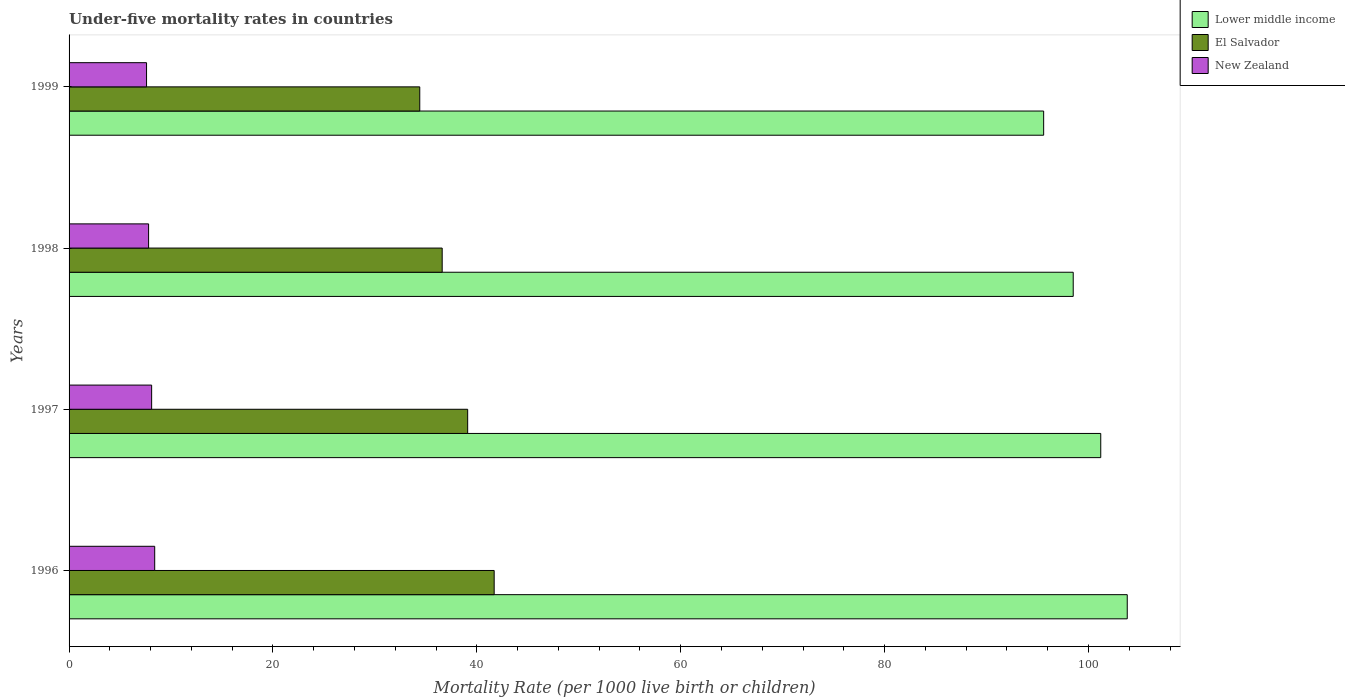How many groups of bars are there?
Your response must be concise. 4. What is the label of the 3rd group of bars from the top?
Ensure brevity in your answer.  1997. What is the under-five mortality rate in Lower middle income in 1997?
Offer a very short reply. 101.2. Across all years, what is the maximum under-five mortality rate in El Salvador?
Give a very brief answer. 41.7. Across all years, what is the minimum under-five mortality rate in Lower middle income?
Your response must be concise. 95.6. What is the total under-five mortality rate in Lower middle income in the graph?
Provide a short and direct response. 399.1. What is the difference between the under-five mortality rate in Lower middle income in 1996 and the under-five mortality rate in El Salvador in 1997?
Keep it short and to the point. 64.7. What is the average under-five mortality rate in New Zealand per year?
Make the answer very short. 7.97. In the year 1998, what is the difference between the under-five mortality rate in New Zealand and under-five mortality rate in Lower middle income?
Give a very brief answer. -90.7. What is the ratio of the under-five mortality rate in New Zealand in 1996 to that in 1997?
Provide a short and direct response. 1.04. Is the under-five mortality rate in El Salvador in 1996 less than that in 1999?
Your answer should be very brief. No. What is the difference between the highest and the second highest under-five mortality rate in Lower middle income?
Offer a terse response. 2.6. What is the difference between the highest and the lowest under-five mortality rate in El Salvador?
Your answer should be compact. 7.3. In how many years, is the under-five mortality rate in New Zealand greater than the average under-five mortality rate in New Zealand taken over all years?
Provide a succinct answer. 2. What does the 2nd bar from the top in 1996 represents?
Provide a short and direct response. El Salvador. What does the 1st bar from the bottom in 1996 represents?
Ensure brevity in your answer.  Lower middle income. How many bars are there?
Keep it short and to the point. 12. Where does the legend appear in the graph?
Offer a very short reply. Top right. How are the legend labels stacked?
Your answer should be compact. Vertical. What is the title of the graph?
Keep it short and to the point. Under-five mortality rates in countries. What is the label or title of the X-axis?
Keep it short and to the point. Mortality Rate (per 1000 live birth or children). What is the label or title of the Y-axis?
Provide a succinct answer. Years. What is the Mortality Rate (per 1000 live birth or children) in Lower middle income in 1996?
Ensure brevity in your answer.  103.8. What is the Mortality Rate (per 1000 live birth or children) of El Salvador in 1996?
Provide a succinct answer. 41.7. What is the Mortality Rate (per 1000 live birth or children) in New Zealand in 1996?
Your response must be concise. 8.4. What is the Mortality Rate (per 1000 live birth or children) of Lower middle income in 1997?
Ensure brevity in your answer.  101.2. What is the Mortality Rate (per 1000 live birth or children) of El Salvador in 1997?
Your answer should be very brief. 39.1. What is the Mortality Rate (per 1000 live birth or children) in New Zealand in 1997?
Offer a very short reply. 8.1. What is the Mortality Rate (per 1000 live birth or children) of Lower middle income in 1998?
Provide a succinct answer. 98.5. What is the Mortality Rate (per 1000 live birth or children) in El Salvador in 1998?
Keep it short and to the point. 36.6. What is the Mortality Rate (per 1000 live birth or children) in Lower middle income in 1999?
Give a very brief answer. 95.6. What is the Mortality Rate (per 1000 live birth or children) in El Salvador in 1999?
Give a very brief answer. 34.4. Across all years, what is the maximum Mortality Rate (per 1000 live birth or children) in Lower middle income?
Your answer should be compact. 103.8. Across all years, what is the maximum Mortality Rate (per 1000 live birth or children) in El Salvador?
Provide a succinct answer. 41.7. Across all years, what is the minimum Mortality Rate (per 1000 live birth or children) of Lower middle income?
Ensure brevity in your answer.  95.6. Across all years, what is the minimum Mortality Rate (per 1000 live birth or children) of El Salvador?
Ensure brevity in your answer.  34.4. What is the total Mortality Rate (per 1000 live birth or children) in Lower middle income in the graph?
Provide a short and direct response. 399.1. What is the total Mortality Rate (per 1000 live birth or children) in El Salvador in the graph?
Provide a short and direct response. 151.8. What is the total Mortality Rate (per 1000 live birth or children) in New Zealand in the graph?
Ensure brevity in your answer.  31.9. What is the difference between the Mortality Rate (per 1000 live birth or children) in Lower middle income in 1996 and that in 1997?
Make the answer very short. 2.6. What is the difference between the Mortality Rate (per 1000 live birth or children) in New Zealand in 1996 and that in 1997?
Provide a short and direct response. 0.3. What is the difference between the Mortality Rate (per 1000 live birth or children) in Lower middle income in 1996 and that in 1998?
Your response must be concise. 5.3. What is the difference between the Mortality Rate (per 1000 live birth or children) of El Salvador in 1996 and that in 1998?
Your answer should be very brief. 5.1. What is the difference between the Mortality Rate (per 1000 live birth or children) in El Salvador in 1996 and that in 1999?
Your answer should be compact. 7.3. What is the difference between the Mortality Rate (per 1000 live birth or children) of New Zealand in 1996 and that in 1999?
Your answer should be compact. 0.8. What is the difference between the Mortality Rate (per 1000 live birth or children) of Lower middle income in 1997 and that in 1998?
Give a very brief answer. 2.7. What is the difference between the Mortality Rate (per 1000 live birth or children) in El Salvador in 1997 and that in 1998?
Give a very brief answer. 2.5. What is the difference between the Mortality Rate (per 1000 live birth or children) in Lower middle income in 1997 and that in 1999?
Make the answer very short. 5.6. What is the difference between the Mortality Rate (per 1000 live birth or children) in El Salvador in 1997 and that in 1999?
Your answer should be very brief. 4.7. What is the difference between the Mortality Rate (per 1000 live birth or children) in Lower middle income in 1998 and that in 1999?
Your response must be concise. 2.9. What is the difference between the Mortality Rate (per 1000 live birth or children) in El Salvador in 1998 and that in 1999?
Your answer should be compact. 2.2. What is the difference between the Mortality Rate (per 1000 live birth or children) of Lower middle income in 1996 and the Mortality Rate (per 1000 live birth or children) of El Salvador in 1997?
Provide a succinct answer. 64.7. What is the difference between the Mortality Rate (per 1000 live birth or children) of Lower middle income in 1996 and the Mortality Rate (per 1000 live birth or children) of New Zealand in 1997?
Ensure brevity in your answer.  95.7. What is the difference between the Mortality Rate (per 1000 live birth or children) in El Salvador in 1996 and the Mortality Rate (per 1000 live birth or children) in New Zealand in 1997?
Keep it short and to the point. 33.6. What is the difference between the Mortality Rate (per 1000 live birth or children) in Lower middle income in 1996 and the Mortality Rate (per 1000 live birth or children) in El Salvador in 1998?
Offer a very short reply. 67.2. What is the difference between the Mortality Rate (per 1000 live birth or children) of Lower middle income in 1996 and the Mortality Rate (per 1000 live birth or children) of New Zealand in 1998?
Make the answer very short. 96. What is the difference between the Mortality Rate (per 1000 live birth or children) in El Salvador in 1996 and the Mortality Rate (per 1000 live birth or children) in New Zealand in 1998?
Provide a short and direct response. 33.9. What is the difference between the Mortality Rate (per 1000 live birth or children) in Lower middle income in 1996 and the Mortality Rate (per 1000 live birth or children) in El Salvador in 1999?
Make the answer very short. 69.4. What is the difference between the Mortality Rate (per 1000 live birth or children) of Lower middle income in 1996 and the Mortality Rate (per 1000 live birth or children) of New Zealand in 1999?
Provide a succinct answer. 96.2. What is the difference between the Mortality Rate (per 1000 live birth or children) in El Salvador in 1996 and the Mortality Rate (per 1000 live birth or children) in New Zealand in 1999?
Your response must be concise. 34.1. What is the difference between the Mortality Rate (per 1000 live birth or children) in Lower middle income in 1997 and the Mortality Rate (per 1000 live birth or children) in El Salvador in 1998?
Ensure brevity in your answer.  64.6. What is the difference between the Mortality Rate (per 1000 live birth or children) of Lower middle income in 1997 and the Mortality Rate (per 1000 live birth or children) of New Zealand in 1998?
Ensure brevity in your answer.  93.4. What is the difference between the Mortality Rate (per 1000 live birth or children) of El Salvador in 1997 and the Mortality Rate (per 1000 live birth or children) of New Zealand in 1998?
Your answer should be very brief. 31.3. What is the difference between the Mortality Rate (per 1000 live birth or children) in Lower middle income in 1997 and the Mortality Rate (per 1000 live birth or children) in El Salvador in 1999?
Keep it short and to the point. 66.8. What is the difference between the Mortality Rate (per 1000 live birth or children) of Lower middle income in 1997 and the Mortality Rate (per 1000 live birth or children) of New Zealand in 1999?
Offer a terse response. 93.6. What is the difference between the Mortality Rate (per 1000 live birth or children) in El Salvador in 1997 and the Mortality Rate (per 1000 live birth or children) in New Zealand in 1999?
Provide a short and direct response. 31.5. What is the difference between the Mortality Rate (per 1000 live birth or children) in Lower middle income in 1998 and the Mortality Rate (per 1000 live birth or children) in El Salvador in 1999?
Your answer should be very brief. 64.1. What is the difference between the Mortality Rate (per 1000 live birth or children) in Lower middle income in 1998 and the Mortality Rate (per 1000 live birth or children) in New Zealand in 1999?
Provide a succinct answer. 90.9. What is the difference between the Mortality Rate (per 1000 live birth or children) in El Salvador in 1998 and the Mortality Rate (per 1000 live birth or children) in New Zealand in 1999?
Your answer should be compact. 29. What is the average Mortality Rate (per 1000 live birth or children) in Lower middle income per year?
Provide a succinct answer. 99.78. What is the average Mortality Rate (per 1000 live birth or children) in El Salvador per year?
Ensure brevity in your answer.  37.95. What is the average Mortality Rate (per 1000 live birth or children) in New Zealand per year?
Provide a short and direct response. 7.97. In the year 1996, what is the difference between the Mortality Rate (per 1000 live birth or children) of Lower middle income and Mortality Rate (per 1000 live birth or children) of El Salvador?
Provide a succinct answer. 62.1. In the year 1996, what is the difference between the Mortality Rate (per 1000 live birth or children) of Lower middle income and Mortality Rate (per 1000 live birth or children) of New Zealand?
Offer a very short reply. 95.4. In the year 1996, what is the difference between the Mortality Rate (per 1000 live birth or children) in El Salvador and Mortality Rate (per 1000 live birth or children) in New Zealand?
Ensure brevity in your answer.  33.3. In the year 1997, what is the difference between the Mortality Rate (per 1000 live birth or children) in Lower middle income and Mortality Rate (per 1000 live birth or children) in El Salvador?
Your answer should be very brief. 62.1. In the year 1997, what is the difference between the Mortality Rate (per 1000 live birth or children) of Lower middle income and Mortality Rate (per 1000 live birth or children) of New Zealand?
Your answer should be very brief. 93.1. In the year 1997, what is the difference between the Mortality Rate (per 1000 live birth or children) in El Salvador and Mortality Rate (per 1000 live birth or children) in New Zealand?
Offer a terse response. 31. In the year 1998, what is the difference between the Mortality Rate (per 1000 live birth or children) in Lower middle income and Mortality Rate (per 1000 live birth or children) in El Salvador?
Provide a succinct answer. 61.9. In the year 1998, what is the difference between the Mortality Rate (per 1000 live birth or children) in Lower middle income and Mortality Rate (per 1000 live birth or children) in New Zealand?
Make the answer very short. 90.7. In the year 1998, what is the difference between the Mortality Rate (per 1000 live birth or children) of El Salvador and Mortality Rate (per 1000 live birth or children) of New Zealand?
Your answer should be very brief. 28.8. In the year 1999, what is the difference between the Mortality Rate (per 1000 live birth or children) of Lower middle income and Mortality Rate (per 1000 live birth or children) of El Salvador?
Provide a short and direct response. 61.2. In the year 1999, what is the difference between the Mortality Rate (per 1000 live birth or children) of Lower middle income and Mortality Rate (per 1000 live birth or children) of New Zealand?
Offer a terse response. 88. In the year 1999, what is the difference between the Mortality Rate (per 1000 live birth or children) in El Salvador and Mortality Rate (per 1000 live birth or children) in New Zealand?
Ensure brevity in your answer.  26.8. What is the ratio of the Mortality Rate (per 1000 live birth or children) in Lower middle income in 1996 to that in 1997?
Make the answer very short. 1.03. What is the ratio of the Mortality Rate (per 1000 live birth or children) of El Salvador in 1996 to that in 1997?
Your answer should be very brief. 1.07. What is the ratio of the Mortality Rate (per 1000 live birth or children) in New Zealand in 1996 to that in 1997?
Provide a short and direct response. 1.04. What is the ratio of the Mortality Rate (per 1000 live birth or children) of Lower middle income in 1996 to that in 1998?
Your answer should be compact. 1.05. What is the ratio of the Mortality Rate (per 1000 live birth or children) of El Salvador in 1996 to that in 1998?
Make the answer very short. 1.14. What is the ratio of the Mortality Rate (per 1000 live birth or children) in New Zealand in 1996 to that in 1998?
Provide a succinct answer. 1.08. What is the ratio of the Mortality Rate (per 1000 live birth or children) in Lower middle income in 1996 to that in 1999?
Give a very brief answer. 1.09. What is the ratio of the Mortality Rate (per 1000 live birth or children) of El Salvador in 1996 to that in 1999?
Offer a terse response. 1.21. What is the ratio of the Mortality Rate (per 1000 live birth or children) of New Zealand in 1996 to that in 1999?
Offer a terse response. 1.11. What is the ratio of the Mortality Rate (per 1000 live birth or children) in Lower middle income in 1997 to that in 1998?
Make the answer very short. 1.03. What is the ratio of the Mortality Rate (per 1000 live birth or children) of El Salvador in 1997 to that in 1998?
Your answer should be very brief. 1.07. What is the ratio of the Mortality Rate (per 1000 live birth or children) in Lower middle income in 1997 to that in 1999?
Your response must be concise. 1.06. What is the ratio of the Mortality Rate (per 1000 live birth or children) in El Salvador in 1997 to that in 1999?
Offer a terse response. 1.14. What is the ratio of the Mortality Rate (per 1000 live birth or children) in New Zealand in 1997 to that in 1999?
Provide a short and direct response. 1.07. What is the ratio of the Mortality Rate (per 1000 live birth or children) of Lower middle income in 1998 to that in 1999?
Ensure brevity in your answer.  1.03. What is the ratio of the Mortality Rate (per 1000 live birth or children) in El Salvador in 1998 to that in 1999?
Your answer should be very brief. 1.06. What is the ratio of the Mortality Rate (per 1000 live birth or children) of New Zealand in 1998 to that in 1999?
Your response must be concise. 1.03. What is the difference between the highest and the second highest Mortality Rate (per 1000 live birth or children) in Lower middle income?
Provide a succinct answer. 2.6. What is the difference between the highest and the second highest Mortality Rate (per 1000 live birth or children) in New Zealand?
Provide a short and direct response. 0.3. What is the difference between the highest and the lowest Mortality Rate (per 1000 live birth or children) of Lower middle income?
Make the answer very short. 8.2. What is the difference between the highest and the lowest Mortality Rate (per 1000 live birth or children) of El Salvador?
Keep it short and to the point. 7.3. What is the difference between the highest and the lowest Mortality Rate (per 1000 live birth or children) in New Zealand?
Keep it short and to the point. 0.8. 